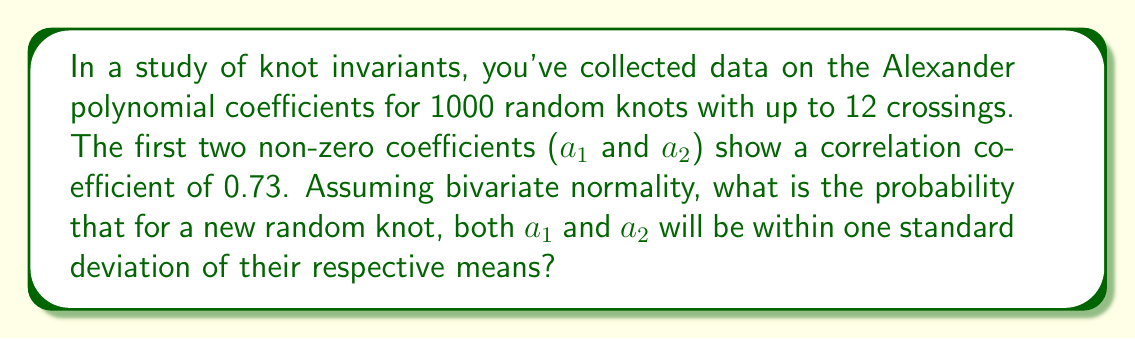Teach me how to tackle this problem. Let's approach this step-by-step:

1) For bivariate normal distribution, the probability that both variables are within one standard deviation of their means is given by the volume under the bivariate normal density within a square region centered at (0,0) with sides of length 2.

2) This probability depends on the correlation coefficient ρ. In our case, ρ = 0.73.

3) The formula for this probability is:

   $$P(|X| \leq 1, |Y| \leq 1) = \frac{4}{\pi} \arcsin(\rho)$$

4) Substituting ρ = 0.73:

   $$P(|X| \leq 1, |Y| \leq 1) = \frac{4}{\pi} \arcsin(0.73)$$

5) Calculate:
   
   $$\frac{4}{\pi} \arcsin(0.73) \approx 0.5146$$

6) Convert to percentage: 0.5146 * 100% ≈ 51.46%

This result suggests that for about 51.46% of new random knots, both a₁ and a₂ will be within one standard deviation of their respective means.
Answer: 51.46% 